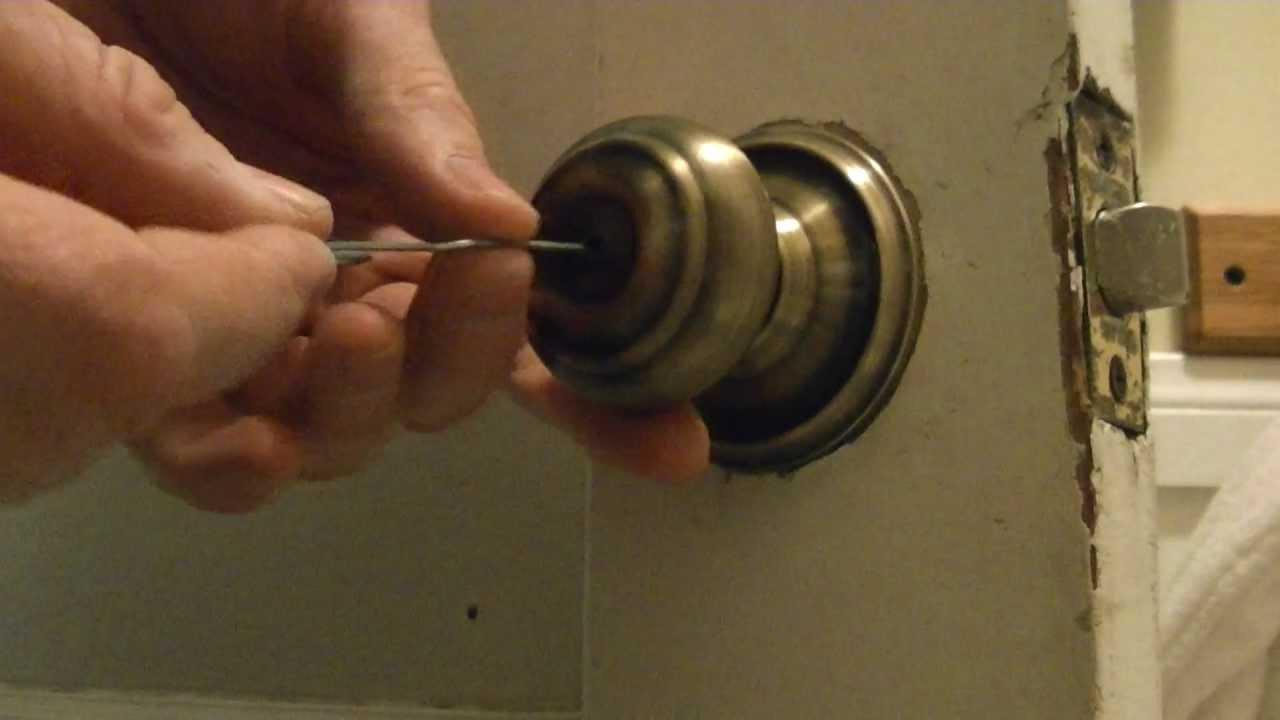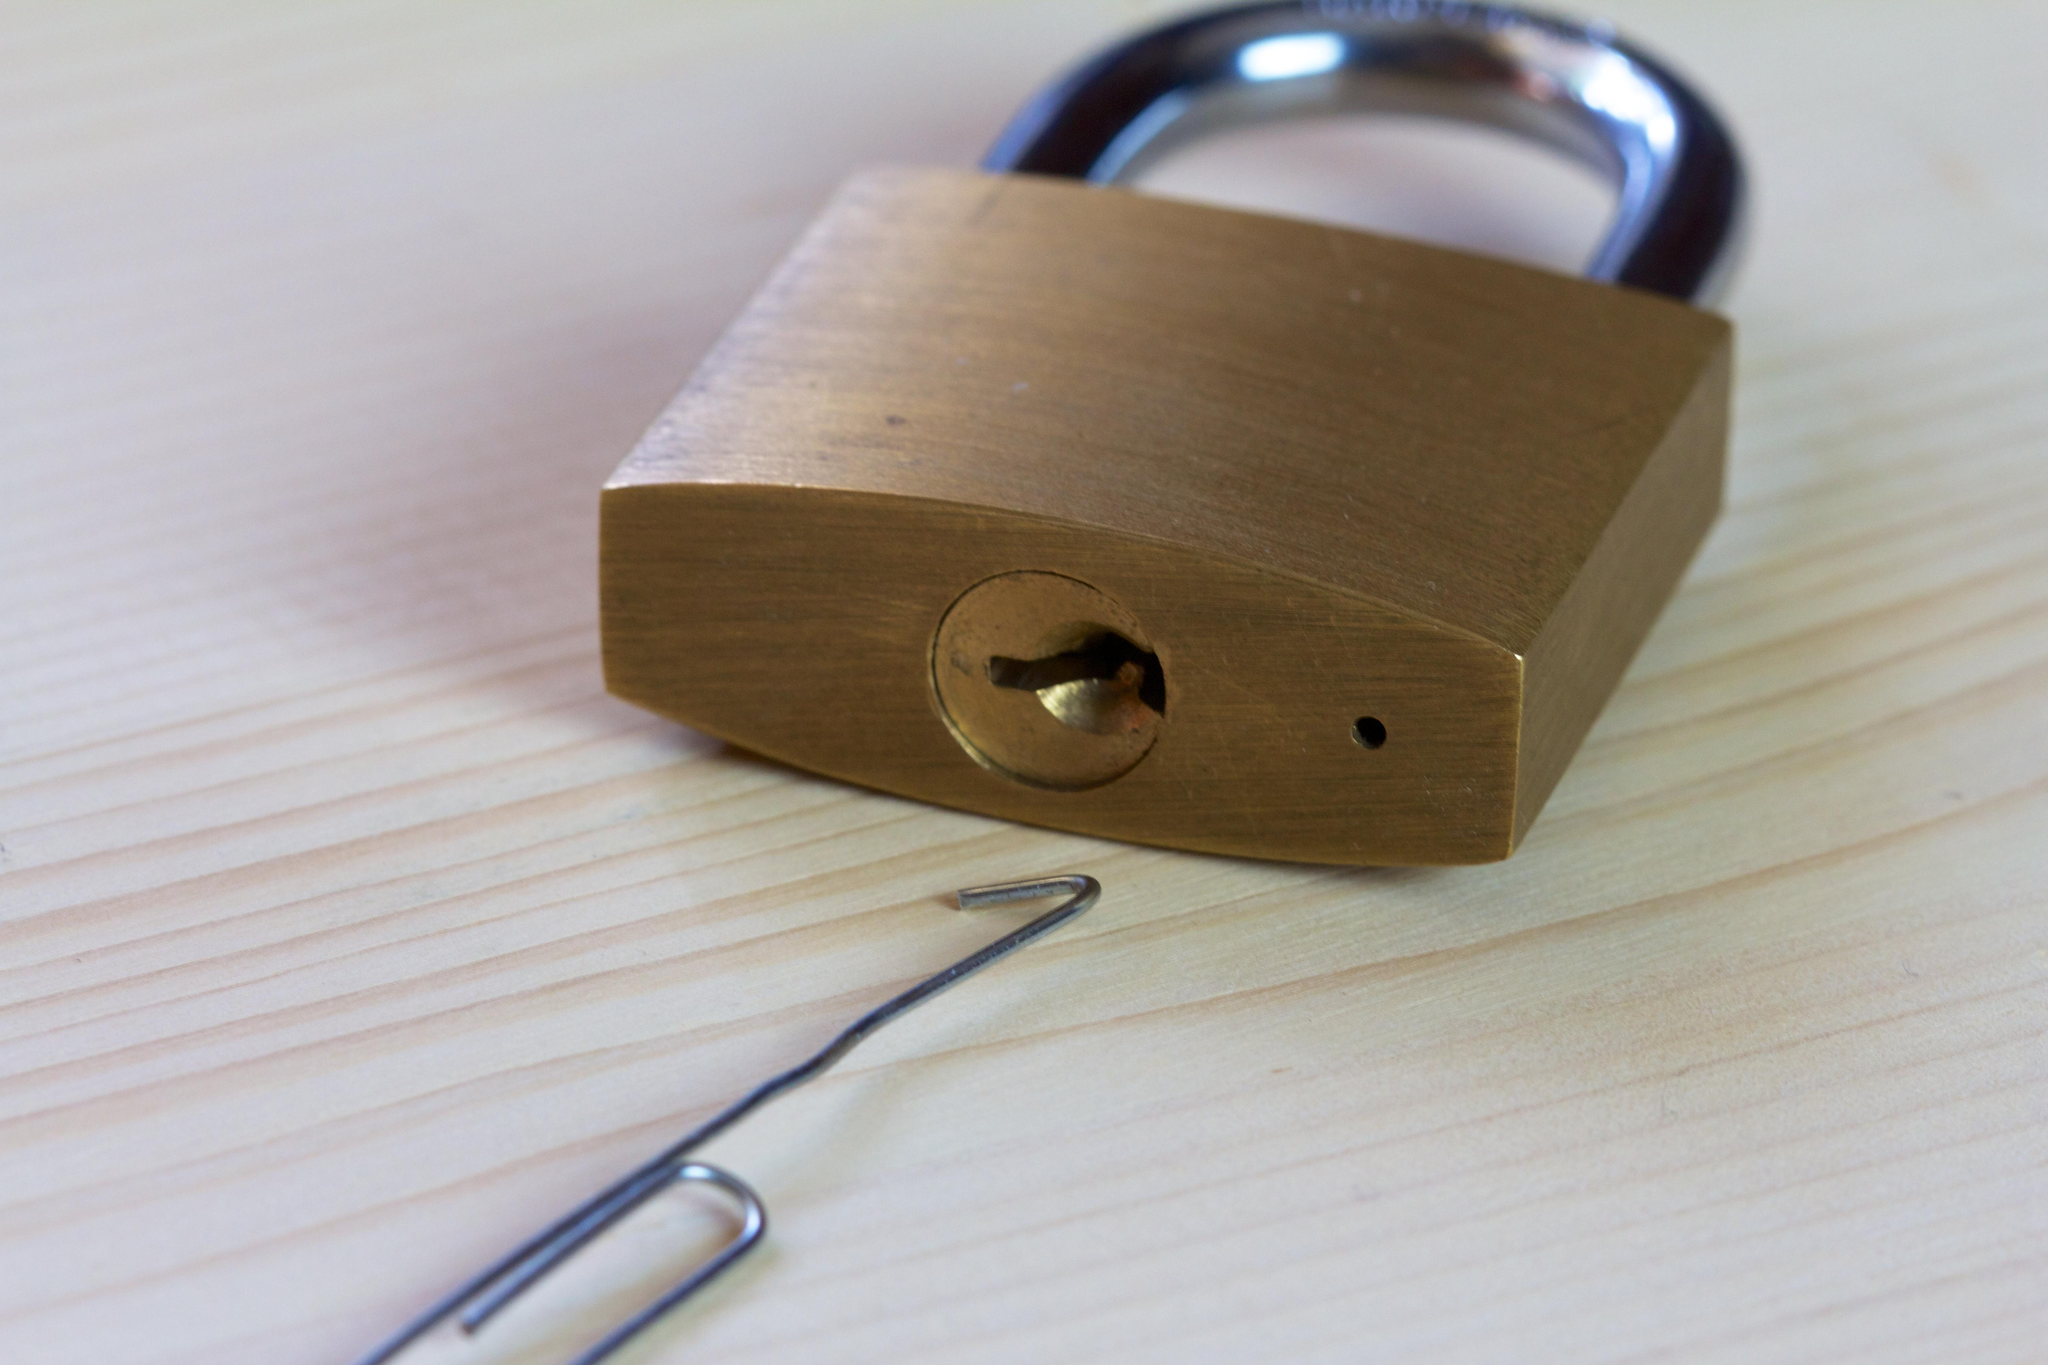The first image is the image on the left, the second image is the image on the right. For the images shown, is this caption "The right image shows a hand inserting something pointed into the keyhole." true? Answer yes or no. No. 